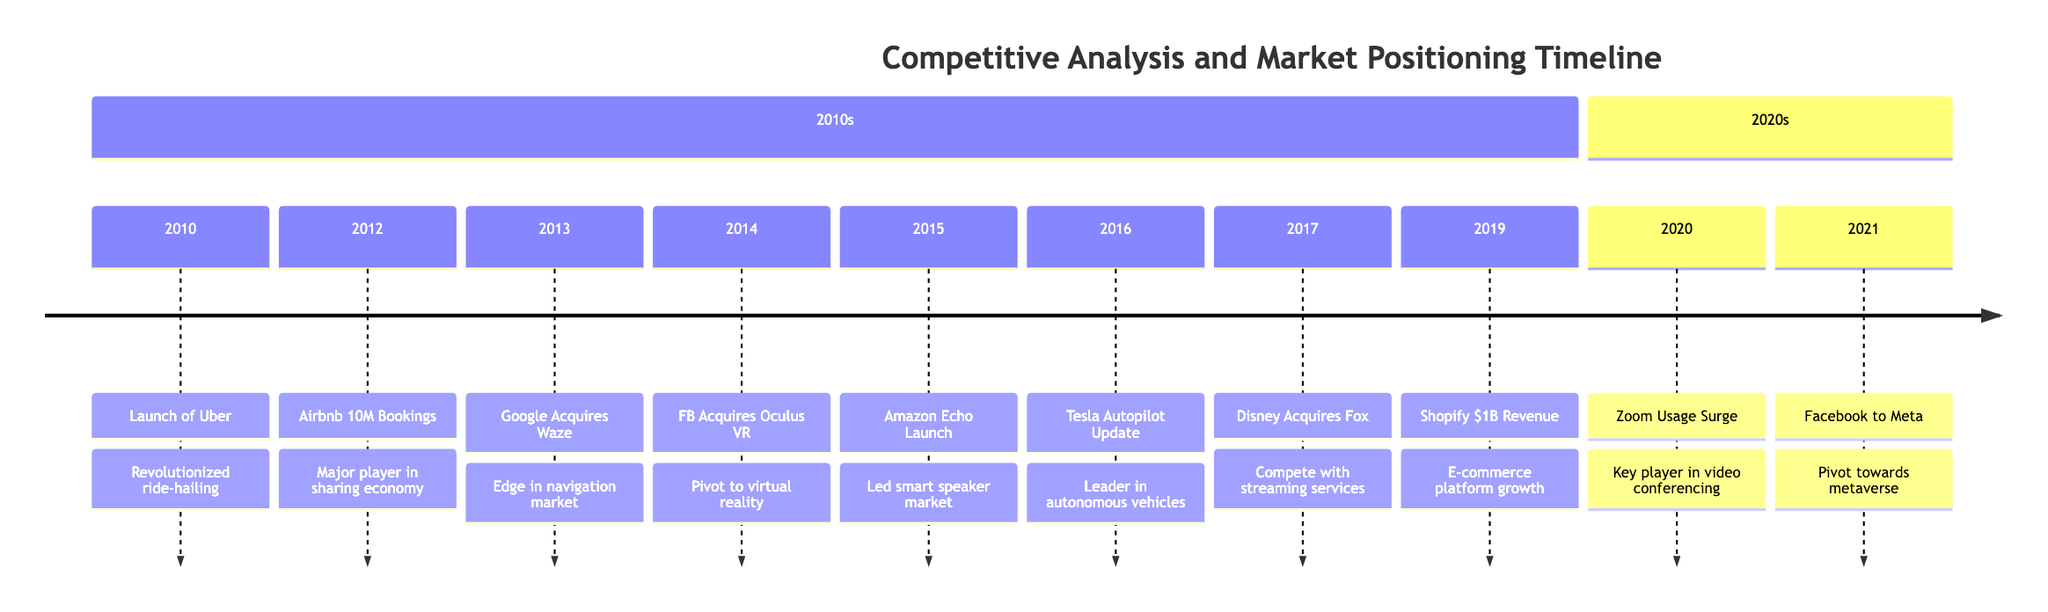What was launched in January 2010? The timeline indicates that in January 2010, Uber was launched. This can be found at the beginning of the timeline.
Answer: Uber How many bookings did Airbnb reach in August 2012? In August 2012, Airbnb reached 10 million bookings. This specific milestone is highlighted in the description of that event.
Answer: 10 million Which company acquired Waze in September 2013? The timeline shows that Google acquired Waze. This is directly stated in the event description from September 2013.
Answer: Google What was the significant pivot for Facebook in October 2021? The timeline indicates that Facebook rebranded to Meta in October 2021, which signifies a major pivot towards the metaverse. This is clearly indicated in the event details.
Answer: Meta In what year did Zoom's usage surge? The timeline notes that Zoom's usage surged in March 2020, making it a key player during the COVID-19 pandemic. This is stated in the date correlated with the surge.
Answer: 2020 Which event marked a significant shift towards virtual reality for Facebook? The timeline shows that Facebook acquired Oculus VR in May 2014, which is a clear indicator of its shift towards virtual reality technologies.
Answer: Oculus VR What was the purpose of Disney's acquisition of 21st Century Fox in December 2017? The timeline describes that Disney's acquisition aimed to improve its content portfolio to compete with streaming services. This provides insight into the strategic reason behind the acquisition in the event description.
Answer: Compete with streaming services Which company entered the smart speaker market in November 2015? According to the timeline, Amazon launched the Echo in November 2015, marking its entry and leadership in the smart speaker market. This specific event is noted in that section of the timeline.
Answer: Amazon What can be inferred about the progression of the timeline from 2010 to 2021? The timeline indicates a series of significant technological advancements and strategic acquisitions, suggesting that the competitive landscape has rapidly evolved. By observing the sequence of events, one can see how companies adapted to market demands and technological shifts.
Answer: Rapid evolution of competition 